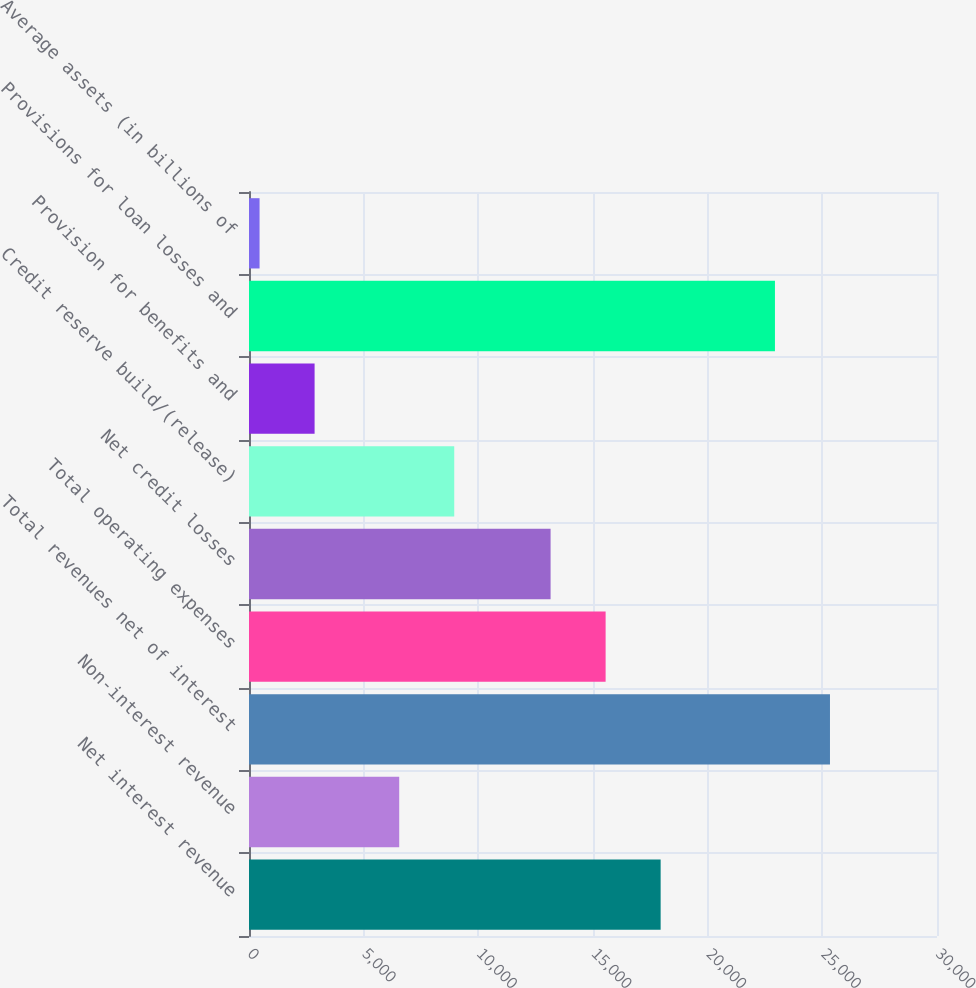<chart> <loc_0><loc_0><loc_500><loc_500><bar_chart><fcel>Net interest revenue<fcel>Non-interest revenue<fcel>Total revenues net of interest<fcel>Total operating expenses<fcel>Net credit losses<fcel>Credit reserve build/(release)<fcel>Provision for benefits and<fcel>Provisions for loan losses and<fcel>Average assets (in billions of<nl><fcel>17949.4<fcel>6550<fcel>25333.2<fcel>15550.2<fcel>13151<fcel>8949.2<fcel>2860.2<fcel>22934<fcel>461<nl></chart> 